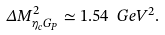<formula> <loc_0><loc_0><loc_500><loc_500>\Delta M _ { \eta _ { c } G _ { P } } ^ { 2 } \simeq 1 . 5 4 \ G e V ^ { 2 } .</formula> 